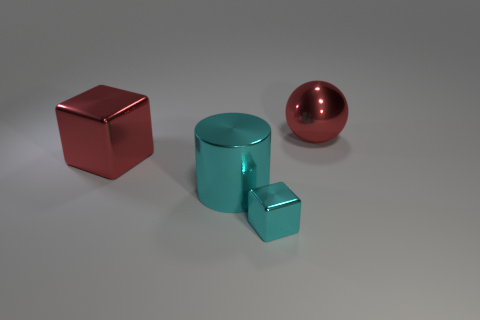Add 4 purple matte blocks. How many objects exist? 8 Subtract all cyan blocks. How many blocks are left? 1 Subtract all cylinders. How many objects are left? 3 Subtract 1 spheres. How many spheres are left? 0 Subtract all blue cylinders. Subtract all yellow blocks. How many cylinders are left? 1 Subtract all blue balls. How many gray cylinders are left? 0 Subtract all small green objects. Subtract all blocks. How many objects are left? 2 Add 2 small things. How many small things are left? 3 Add 3 large red metal spheres. How many large red metal spheres exist? 4 Subtract 0 purple cubes. How many objects are left? 4 